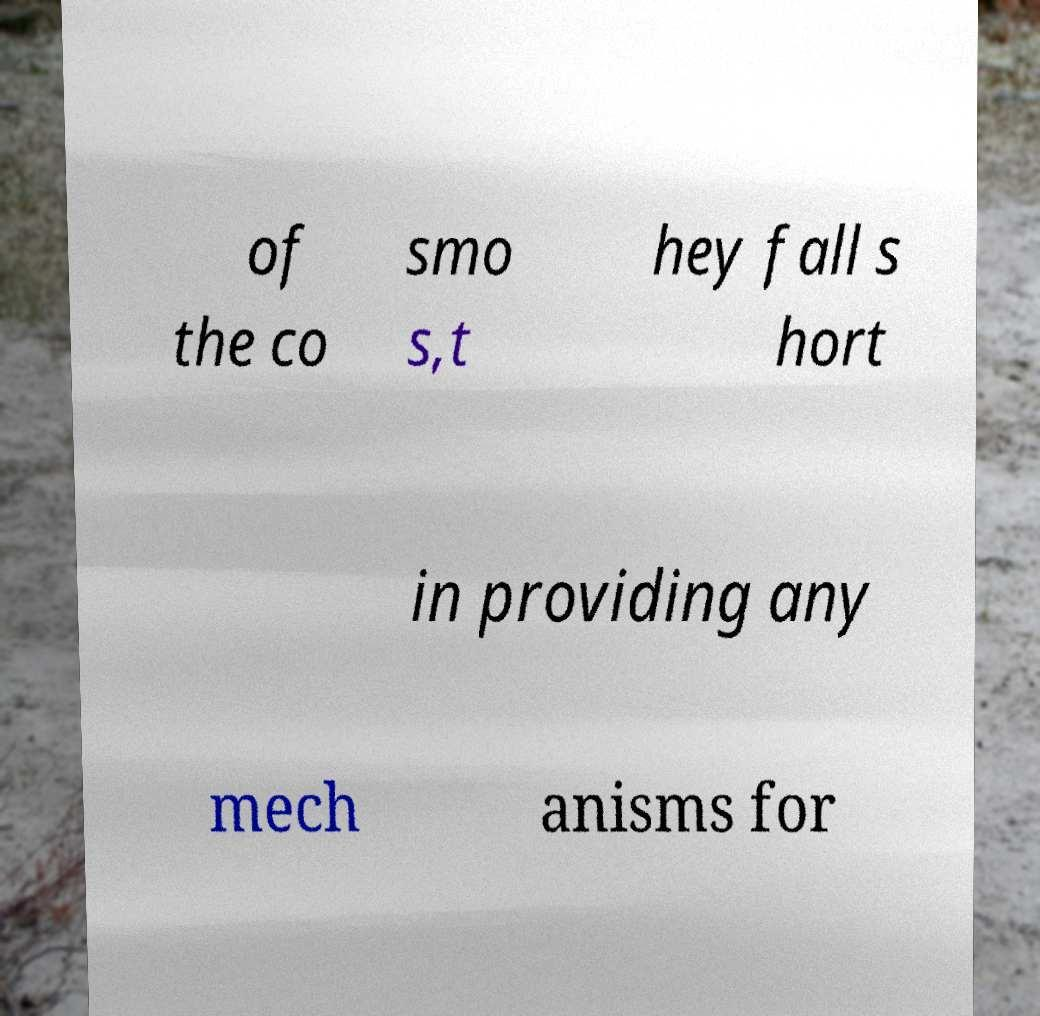Could you assist in decoding the text presented in this image and type it out clearly? of the co smo s,t hey fall s hort in providing any mech anisms for 